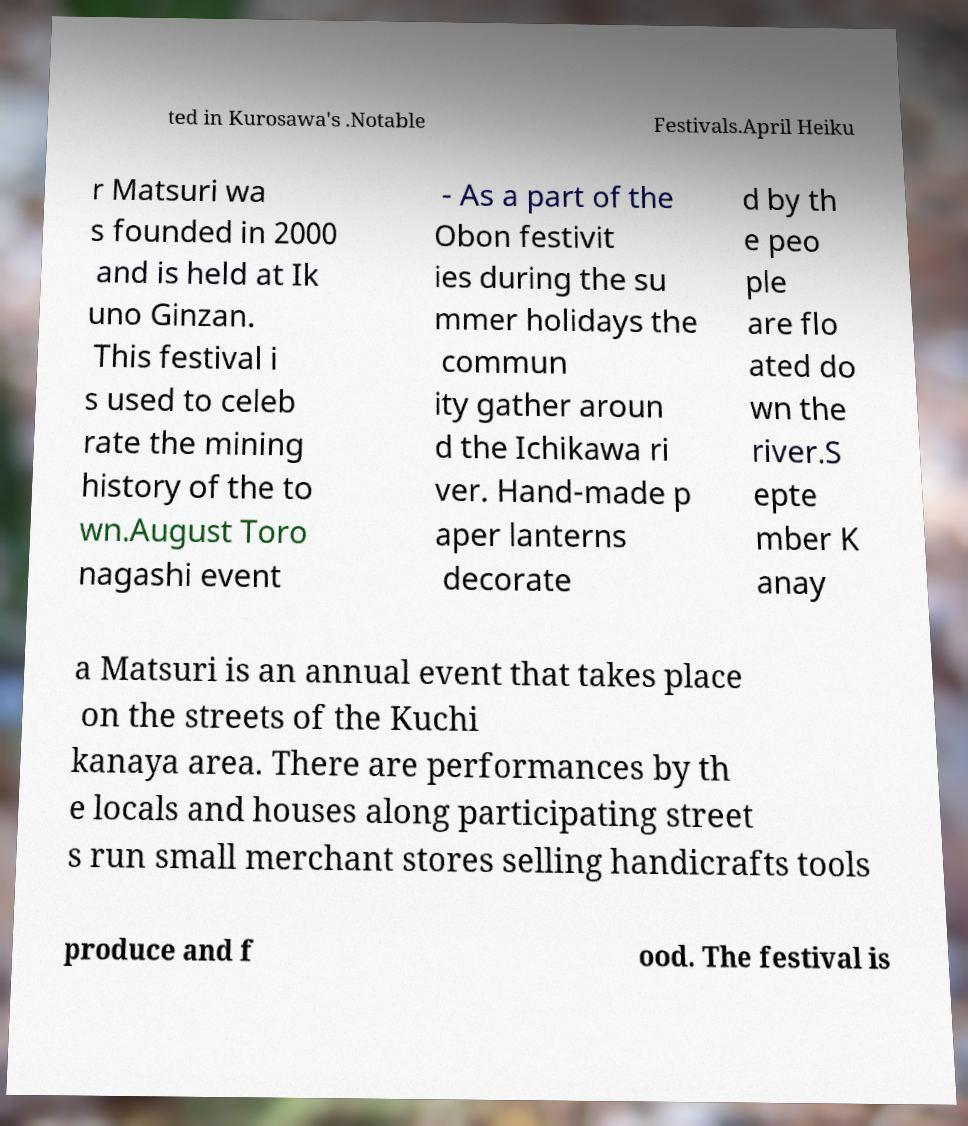Please identify and transcribe the text found in this image. ted in Kurosawa's .Notable Festivals.April Heiku r Matsuri wa s founded in 2000 and is held at Ik uno Ginzan. This festival i s used to celeb rate the mining history of the to wn.August Toro nagashi event - As a part of the Obon festivit ies during the su mmer holidays the commun ity gather aroun d the Ichikawa ri ver. Hand-made p aper lanterns decorate d by th e peo ple are flo ated do wn the river.S epte mber K anay a Matsuri is an annual event that takes place on the streets of the Kuchi kanaya area. There are performances by th e locals and houses along participating street s run small merchant stores selling handicrafts tools produce and f ood. The festival is 